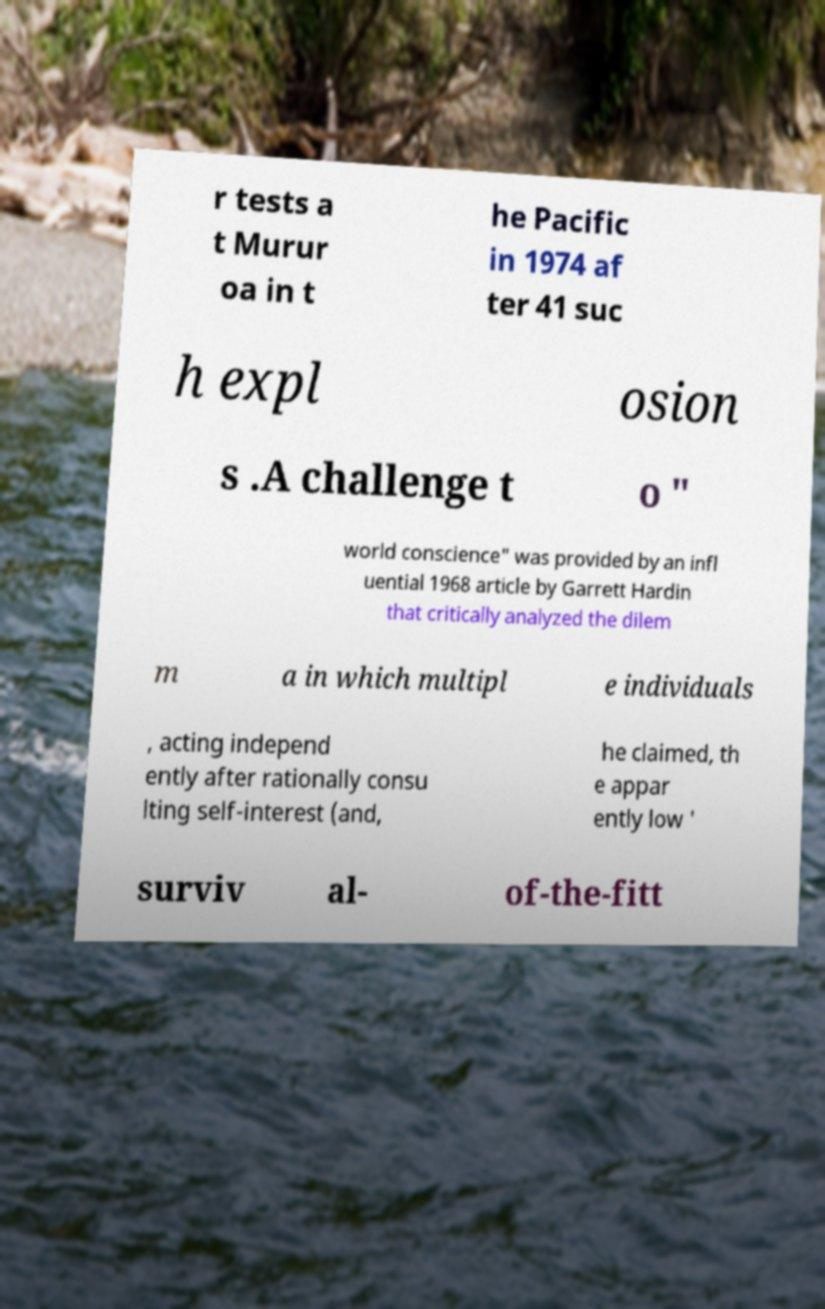What messages or text are displayed in this image? I need them in a readable, typed format. r tests a t Murur oa in t he Pacific in 1974 af ter 41 suc h expl osion s .A challenge t o " world conscience" was provided by an infl uential 1968 article by Garrett Hardin that critically analyzed the dilem m a in which multipl e individuals , acting independ ently after rationally consu lting self-interest (and, he claimed, th e appar ently low ' surviv al- of-the-fitt 